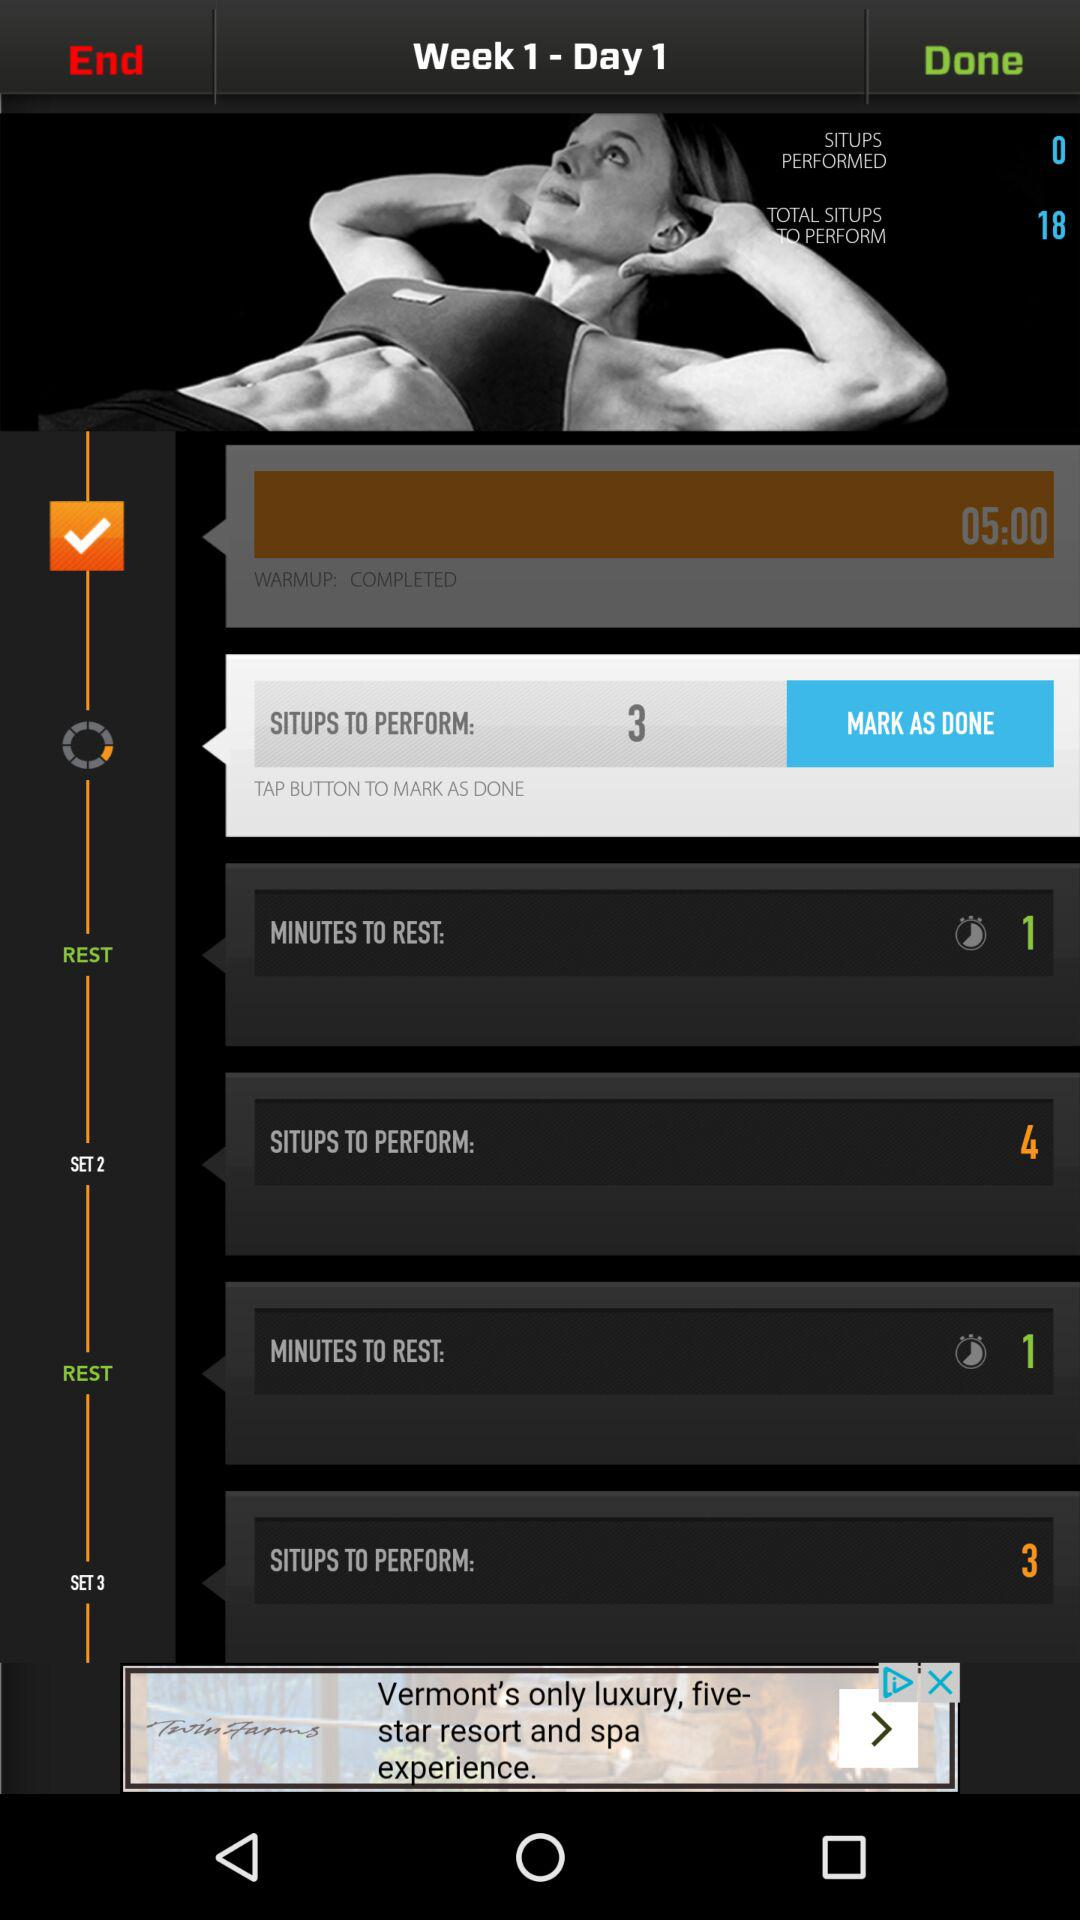How many situps are there to perform in Set 2? There are 4 situps to perform in Set 2. 